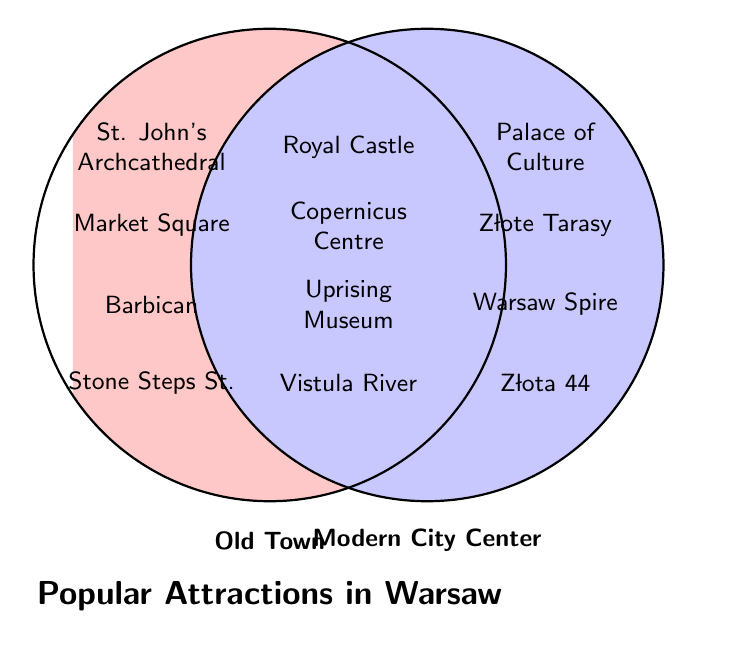Which attractions are shared between Old Town and Modern City Center? The central area where the two circles overlap lists the attractions common to both areas: Royal Castle, Copernicus Science Centre, Warsaw Uprising Museum, Vistula River Boulevards, Lazienki Park, Saxon Garden.
Answer: Royal Castle, Copernicus Science Centre, Warsaw Uprising Museum, Vistula River Boulevards, Lazienki Park, Saxon Garden How many attractions are exclusive to the Old Town? The circle labeled "Old Town" on the left contains attractions exclusive to this area: St. John's Archcathedral, Market Square, Barbican, Stone Steps Street, Warsaw Mermaid statue, The Gnome. There are 6 items.
Answer: 6 Which section has Złota 44 Skyscraper? The "Modern City Center" circle on the right contains Złota 44 Skyscraper.
Answer: Modern City Center Which area has the Palace of Culture and Science? The right circle labeled "Modern City Center" lists the Palace of Culture and Science under exclusive attractions.
Answer: Modern City Center Name an attraction found in both the Old Town and Modern City Center related to history. The Warsaw Uprising Museum is an attraction in the overlapping section and is related to history.
Answer: Warsaw Uprising Museum How many attractions are found in both the Old Town and Modern City Center? The overlap area where both circles intersect contains the shared attractions: Royal Castle, Copernicus Science Centre, Warsaw Uprising Museum, Vistula River Boulevards, Lazienki Park, Saxon Garden. There are 6 items.
Answer: 6 Which section would you find the Warsaw Mermaid statue? The "Old Town" circle on the left lists the Warsaw Mermaid statue under exclusive attractions.
Answer: Old Town How many total unique attractions are listed in the figure for both Old Town and Modern City Center combined? Count all unique attractions from the left, right, and center sections. There are 6 exclusive to Old Town, 6 exclusive to Modern City Center, and 6 shared, making a total of 18 unique attractions.
Answer: 18 Which of the two areas has a specific attraction called the "Vistula River Boulevards"? The Vistula River Boulevards is listed in the overlapping center section, meaning it is present in both the Old Town and Modern City Center.
Answer: Both Is the POLIN Museum found in Old Town, Modern City Center, or both? The POLIN Museum is listed in the right circle labeled "Modern City Center".
Answer: Modern City Center 